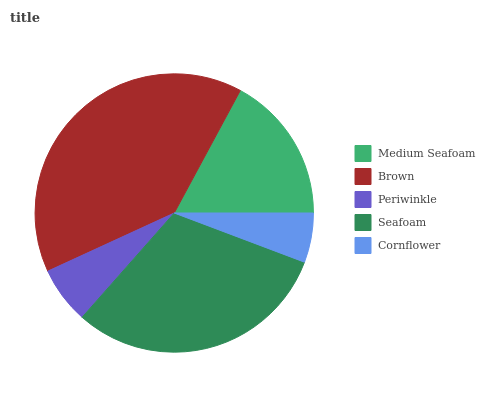Is Cornflower the minimum?
Answer yes or no. Yes. Is Brown the maximum?
Answer yes or no. Yes. Is Periwinkle the minimum?
Answer yes or no. No. Is Periwinkle the maximum?
Answer yes or no. No. Is Brown greater than Periwinkle?
Answer yes or no. Yes. Is Periwinkle less than Brown?
Answer yes or no. Yes. Is Periwinkle greater than Brown?
Answer yes or no. No. Is Brown less than Periwinkle?
Answer yes or no. No. Is Medium Seafoam the high median?
Answer yes or no. Yes. Is Medium Seafoam the low median?
Answer yes or no. Yes. Is Cornflower the high median?
Answer yes or no. No. Is Cornflower the low median?
Answer yes or no. No. 